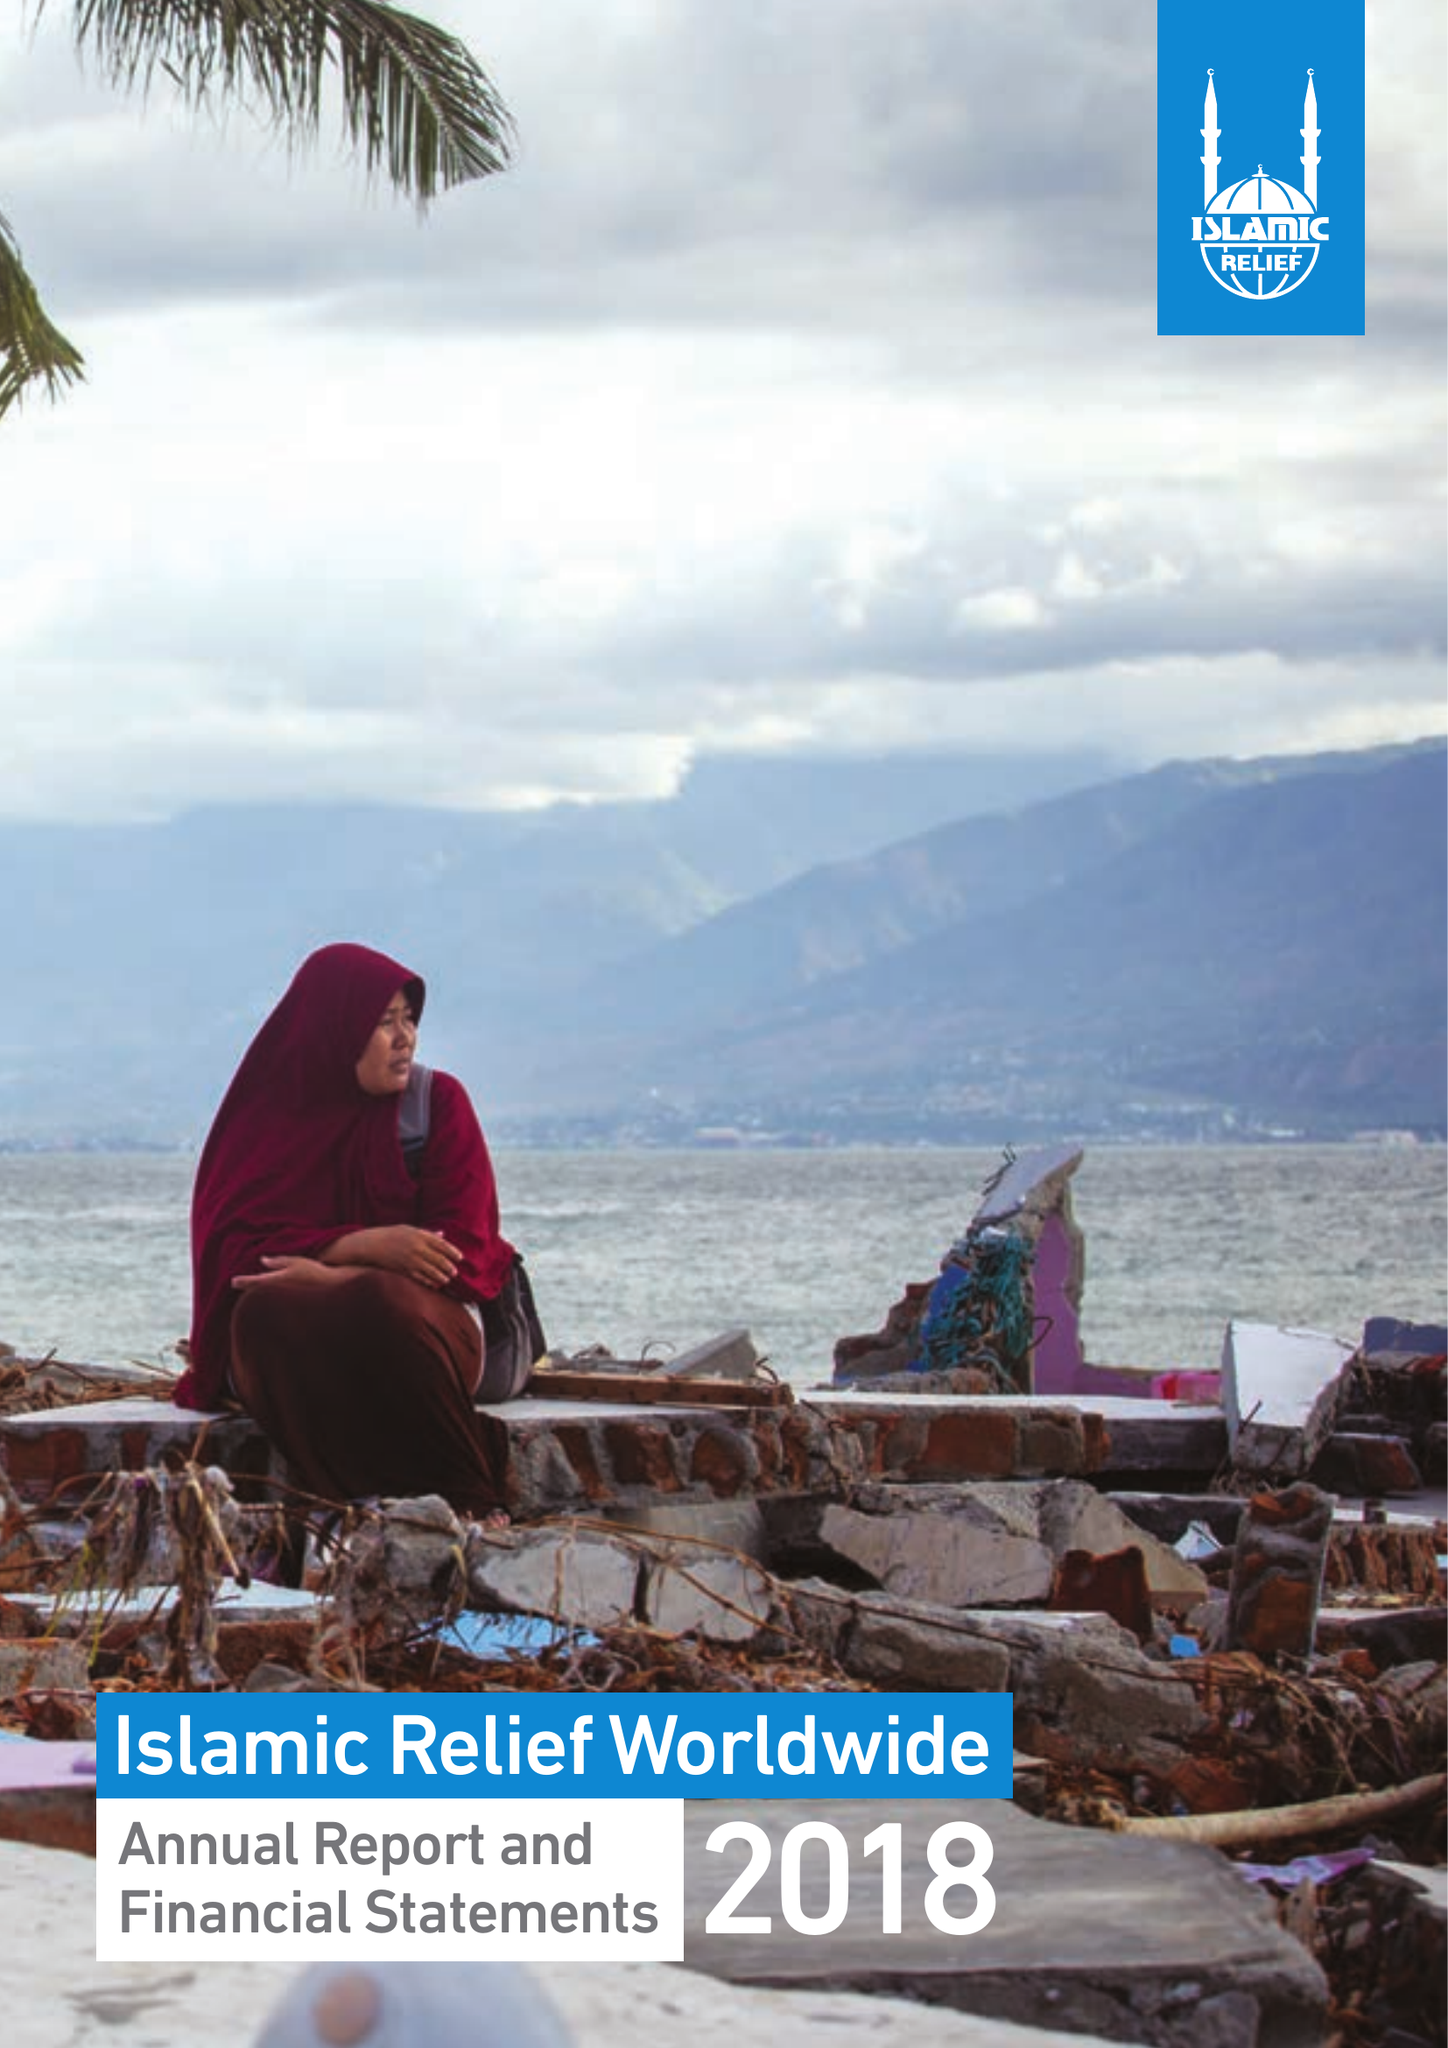What is the value for the address__street_line?
Answer the question using a single word or phrase. 19 REA STREET SOUTH 